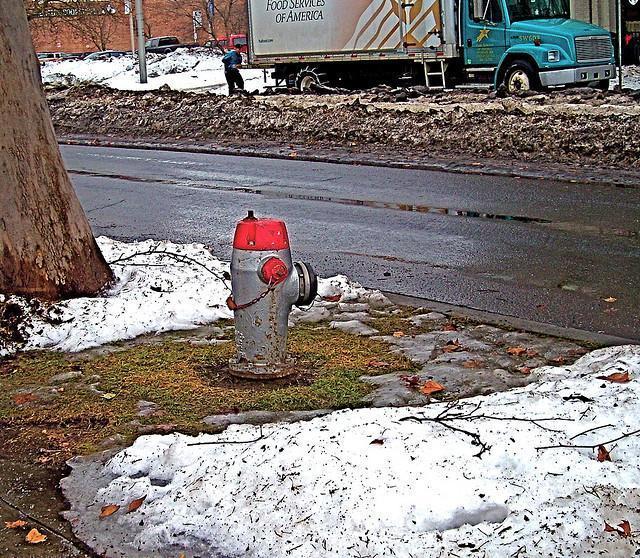How many birds are in the photograph?
Give a very brief answer. 0. 